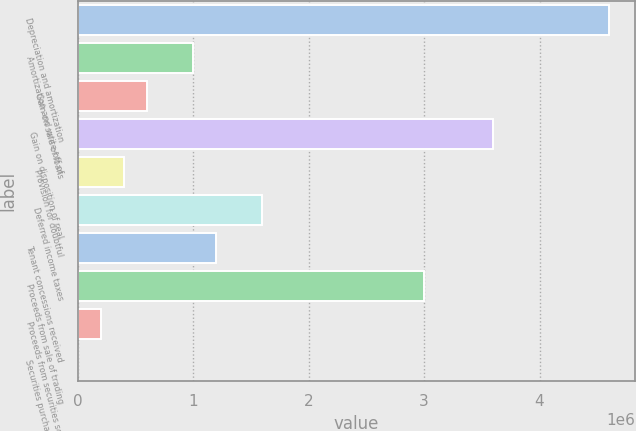<chart> <loc_0><loc_0><loc_500><loc_500><bar_chart><fcel>Depreciation and amortization<fcel>Amortization and write-off of<fcel>Gain on sale of loans<fcel>Gain on disposition of real<fcel>Provision for doubtful<fcel>Deferred income taxes<fcel>Tenant concessions received<fcel>Proceeds from sale of trading<fcel>Proceeds from securities sold<fcel>Securities purchased to cover<nl><fcel>4.59808e+06<fcel>999938<fcel>600144<fcel>3.5986e+06<fcel>400247<fcel>1.59963e+06<fcel>1.19983e+06<fcel>2.99891e+06<fcel>200350<fcel>453<nl></chart> 